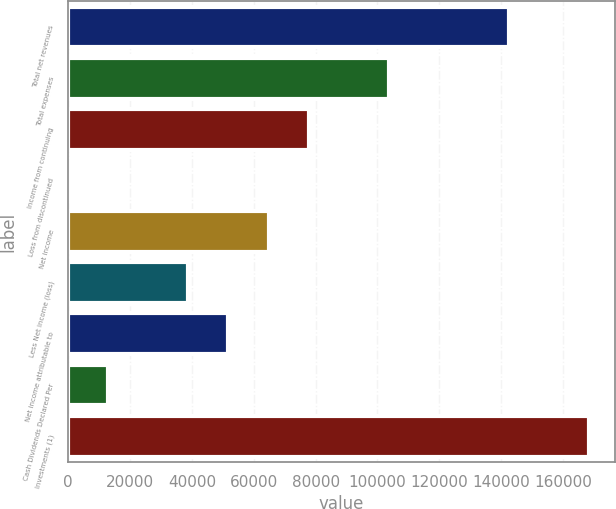Convert chart to OTSL. <chart><loc_0><loc_0><loc_500><loc_500><bar_chart><fcel>Total net revenues<fcel>Total expenses<fcel>Income from continuing<fcel>Loss from discontinued<fcel>Net income<fcel>Less Net income (loss)<fcel>Net income attributable to<fcel>Cash Dividends Declared Per<fcel>Investments (1)<nl><fcel>142475<fcel>103618<fcel>77713.8<fcel>0.1<fcel>64761.6<fcel>38857<fcel>51809.3<fcel>12952.4<fcel>168380<nl></chart> 